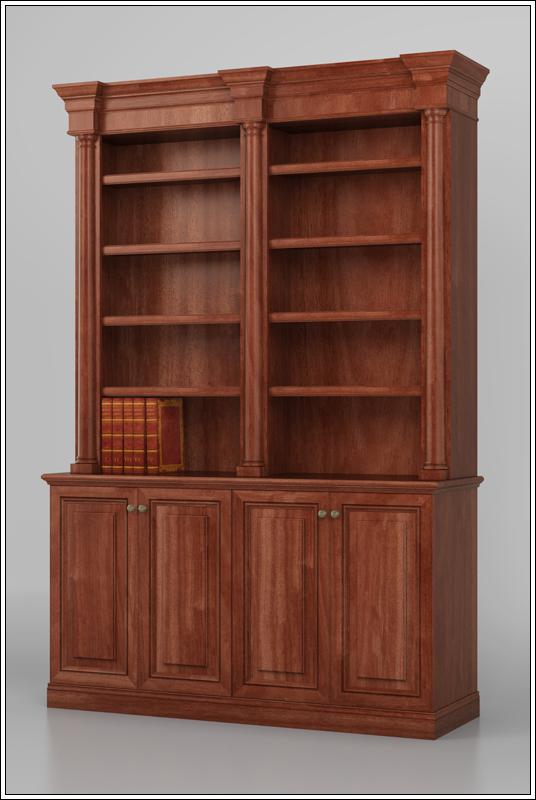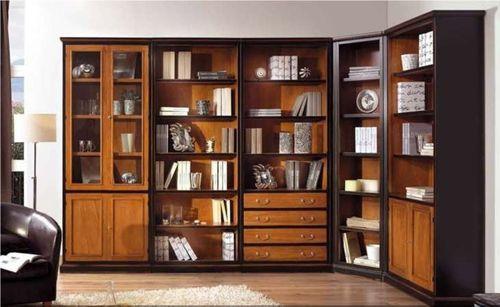The first image is the image on the left, the second image is the image on the right. For the images shown, is this caption "There is an empty case of bookshelf." true? Answer yes or no. Yes. 